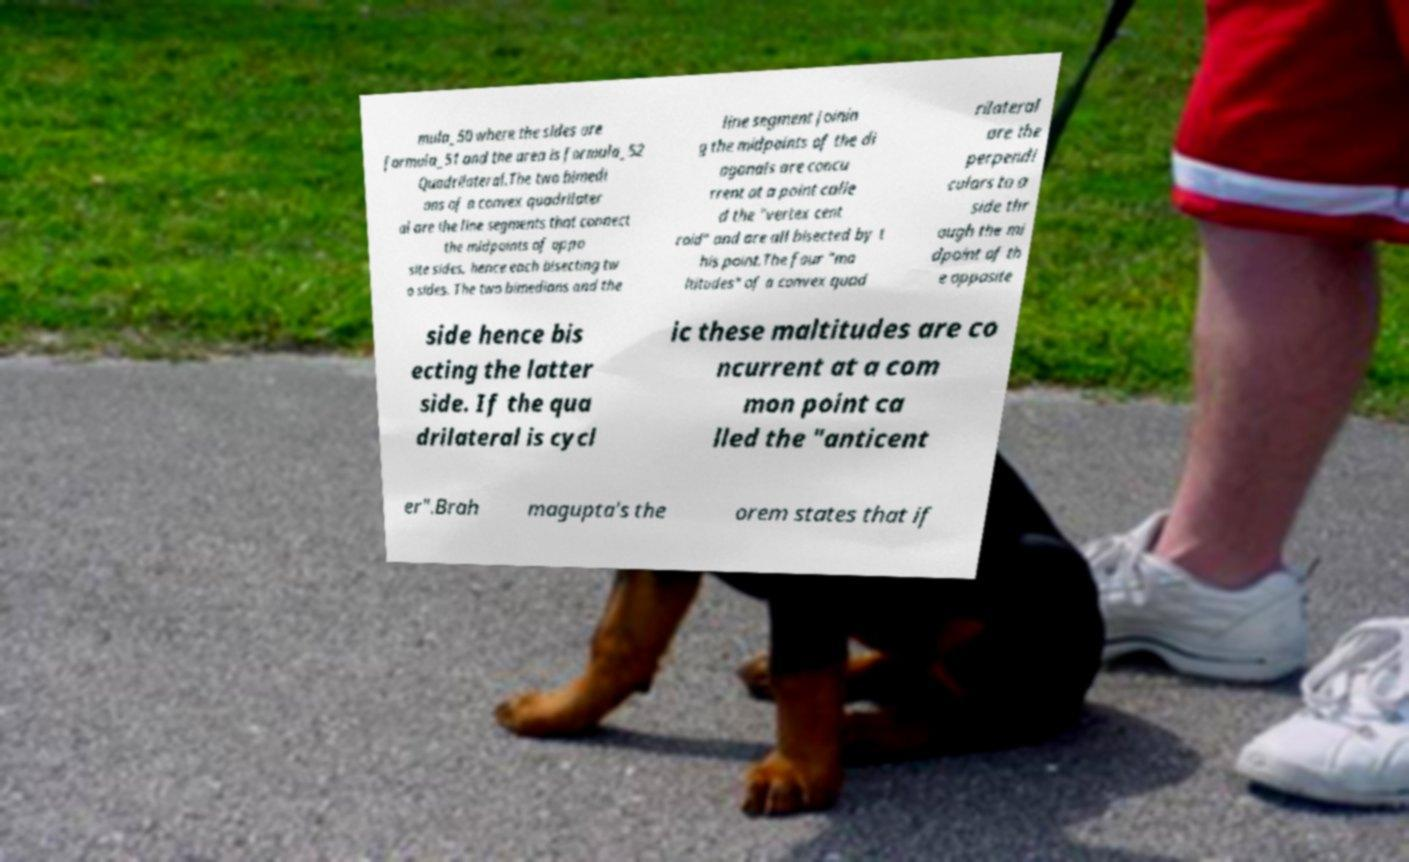For documentation purposes, I need the text within this image transcribed. Could you provide that? mula_50 where the sides are formula_51 and the area is formula_52 Quadrilateral.The two bimedi ans of a convex quadrilater al are the line segments that connect the midpoints of oppo site sides, hence each bisecting tw o sides. The two bimedians and the line segment joinin g the midpoints of the di agonals are concu rrent at a point calle d the "vertex cent roid" and are all bisected by t his point.The four "ma ltitudes" of a convex quad rilateral are the perpendi culars to a side thr ough the mi dpoint of th e opposite side hence bis ecting the latter side. If the qua drilateral is cycl ic these maltitudes are co ncurrent at a com mon point ca lled the "anticent er".Brah magupta's the orem states that if 